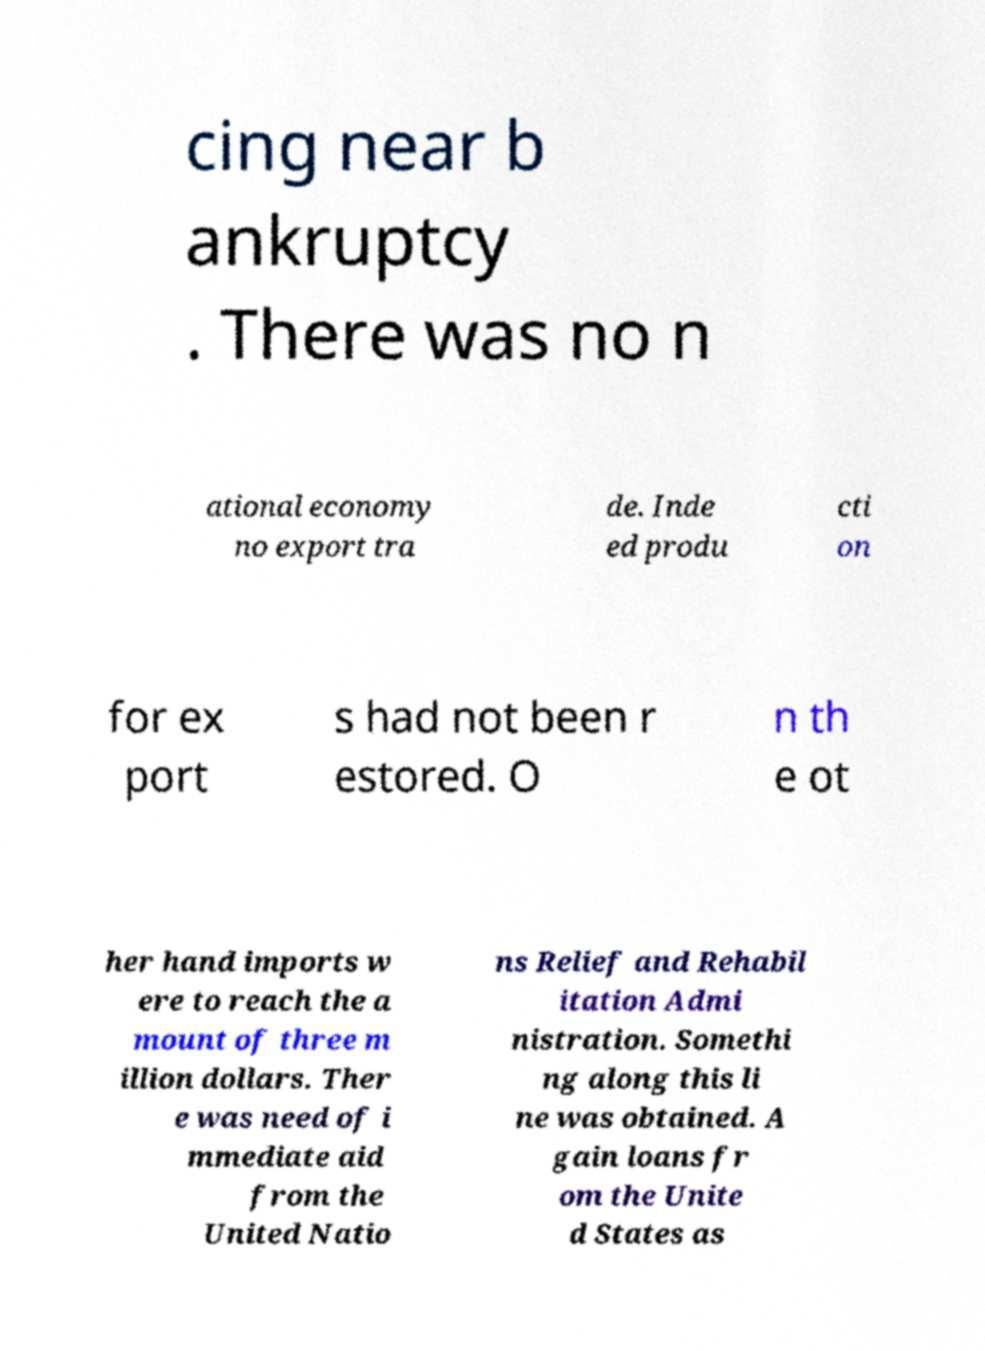Could you assist in decoding the text presented in this image and type it out clearly? cing near b ankruptcy . There was no n ational economy no export tra de. Inde ed produ cti on for ex port s had not been r estored. O n th e ot her hand imports w ere to reach the a mount of three m illion dollars. Ther e was need of i mmediate aid from the United Natio ns Relief and Rehabil itation Admi nistration. Somethi ng along this li ne was obtained. A gain loans fr om the Unite d States as 